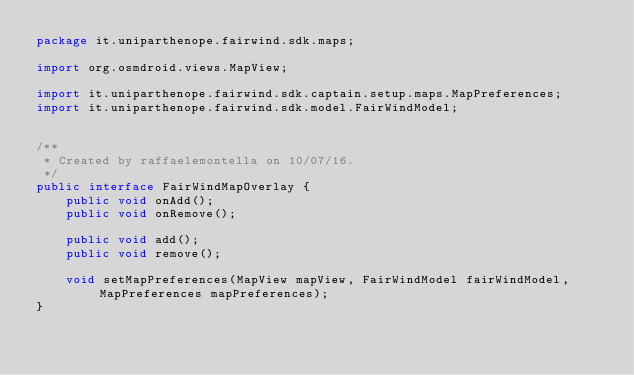Convert code to text. <code><loc_0><loc_0><loc_500><loc_500><_Java_>package it.uniparthenope.fairwind.sdk.maps;

import org.osmdroid.views.MapView;

import it.uniparthenope.fairwind.sdk.captain.setup.maps.MapPreferences;
import it.uniparthenope.fairwind.sdk.model.FairWindModel;


/**
 * Created by raffaelemontella on 10/07/16.
 */
public interface FairWindMapOverlay {
    public void onAdd();
    public void onRemove();

    public void add();
    public void remove();

    void setMapPreferences(MapView mapView, FairWindModel fairWindModel, MapPreferences mapPreferences);
}
</code> 